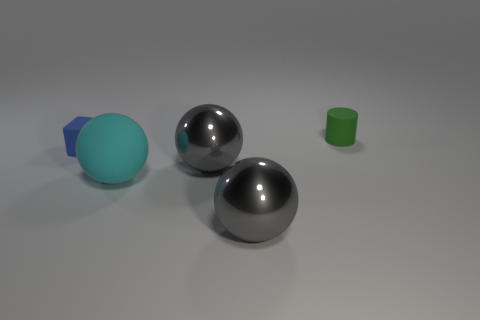Subtract all gray spheres. How many spheres are left? 1 Subtract all gray cylinders. How many gray balls are left? 2 Add 3 small green blocks. How many objects exist? 8 Subtract 1 balls. How many balls are left? 2 Subtract all blocks. How many objects are left? 4 Subtract all big brown objects. Subtract all rubber objects. How many objects are left? 2 Add 5 cyan balls. How many cyan balls are left? 6 Add 5 small green objects. How many small green objects exist? 6 Subtract 0 blue cylinders. How many objects are left? 5 Subtract all brown blocks. Subtract all yellow spheres. How many blocks are left? 1 